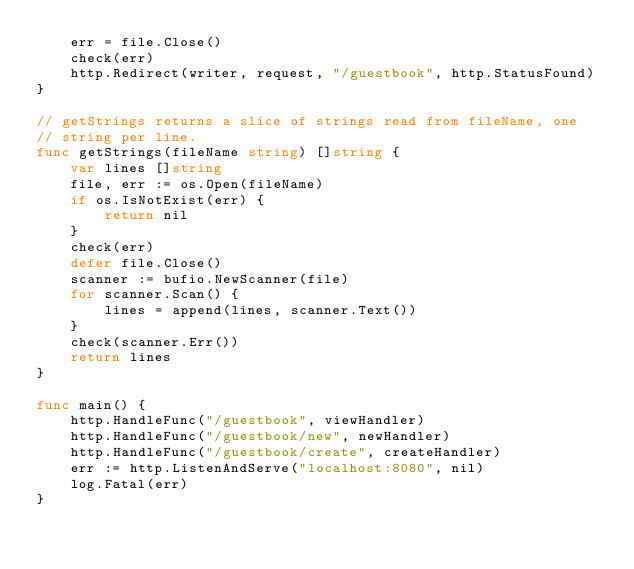<code> <loc_0><loc_0><loc_500><loc_500><_Go_>	err = file.Close()
	check(err)
	http.Redirect(writer, request, "/guestbook", http.StatusFound)
}

// getStrings returns a slice of strings read from fileName, one
// string per line.
func getStrings(fileName string) []string {
	var lines []string
	file, err := os.Open(fileName)
	if os.IsNotExist(err) {
		return nil
	}
	check(err)
	defer file.Close()
	scanner := bufio.NewScanner(file)
	for scanner.Scan() {
		lines = append(lines, scanner.Text())
	}
	check(scanner.Err())
	return lines
}

func main() {
	http.HandleFunc("/guestbook", viewHandler)
	http.HandleFunc("/guestbook/new", newHandler)
	http.HandleFunc("/guestbook/create", createHandler)
	err := http.ListenAndServe("localhost:8080", nil)
	log.Fatal(err)
}
</code> 